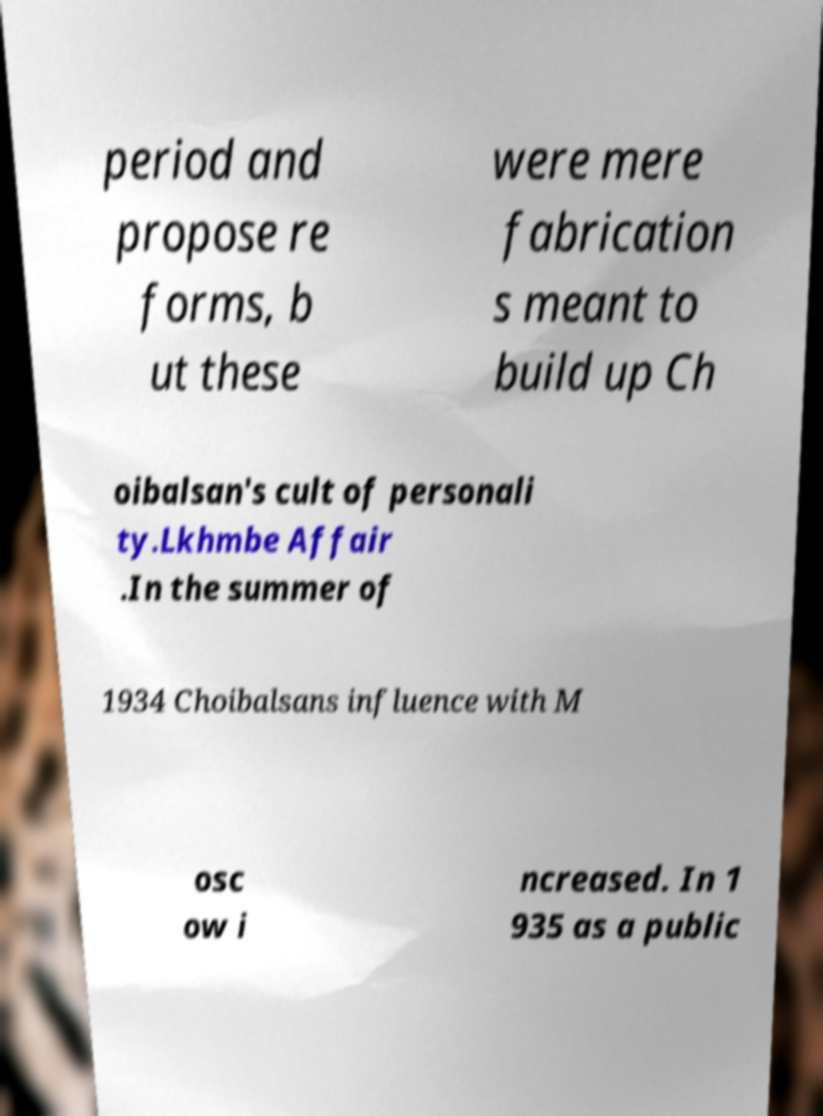I need the written content from this picture converted into text. Can you do that? period and propose re forms, b ut these were mere fabrication s meant to build up Ch oibalsan's cult of personali ty.Lkhmbe Affair .In the summer of 1934 Choibalsans influence with M osc ow i ncreased. In 1 935 as a public 